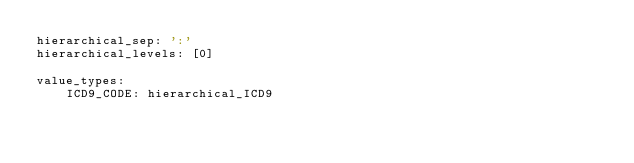<code> <loc_0><loc_0><loc_500><loc_500><_YAML_>hierarchical_sep: ':'
hierarchical_levels: [0]

value_types:
    ICD9_CODE: hierarchical_ICD9
</code> 